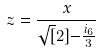Convert formula to latex. <formula><loc_0><loc_0><loc_500><loc_500>z = \frac { x } { \sqrt { [ } 2 ] { - \frac { i _ { 6 } } { 3 } } }</formula> 